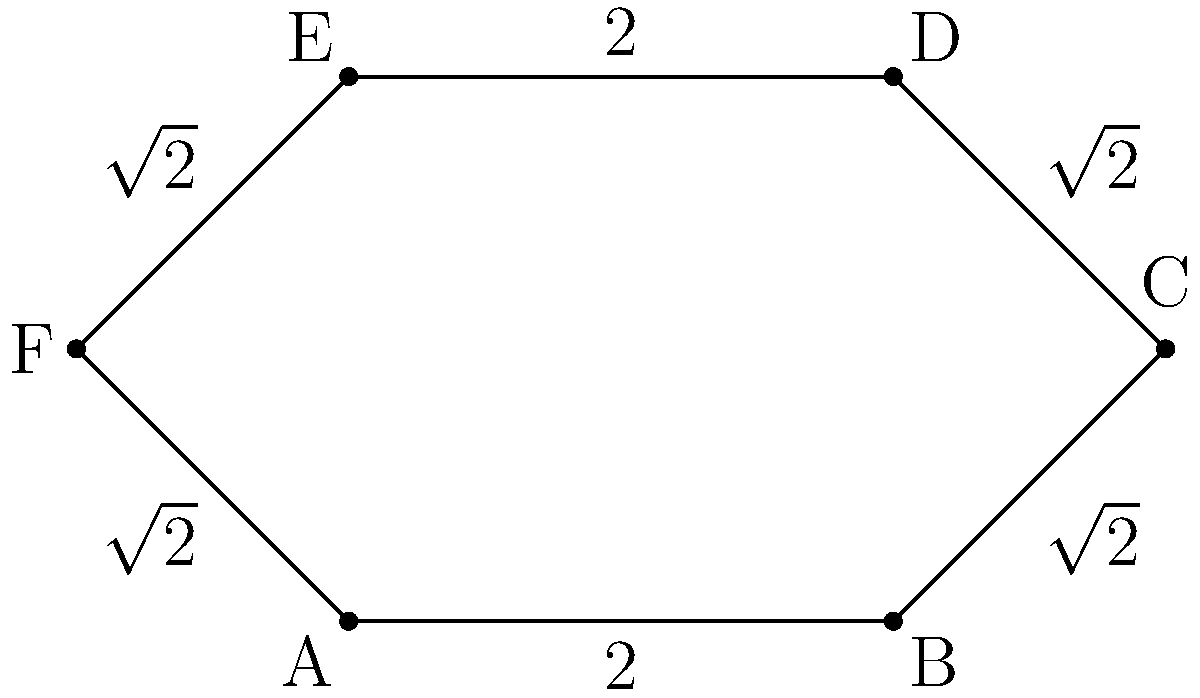Given the star-shaped polygon ABCDEF, where AB = DE = 2 units, and BC = CD = EF = FA = $\sqrt{2}$ units, calculate the perimeter of the polygon. Round your answer to two decimal places if necessary. To find the perimeter of the star-shaped polygon, we need to sum up the lengths of all sides. Let's break it down step by step:

1. Identify the given side lengths:
   - AB = 2 units
   - BC = $\sqrt{2}$ units
   - CD = $\sqrt{2}$ units
   - DE = 2 units
   - EF = $\sqrt{2}$ units
   - FA = $\sqrt{2}$ units

2. Sum up all the side lengths:
   Perimeter = AB + BC + CD + DE + EF + FA
   Perimeter = 2 + $\sqrt{2}$ + $\sqrt{2}$ + 2 + $\sqrt{2}$ + $\sqrt{2}$
   Perimeter = 4 + 4$\sqrt{2}$

3. Simplify the expression:
   Perimeter = 4 + 4$\sqrt{2}$
   
4. Calculate the value of 4$\sqrt{2}$:
   4$\sqrt{2}$ ≈ 5.6569

5. Add the results:
   Perimeter ≈ 4 + 5.6569 = 9.6569

6. Round to two decimal places:
   Perimeter ≈ 9.66 units

Therefore, the perimeter of the star-shaped polygon is approximately 9.66 units.
Answer: 9.66 units 